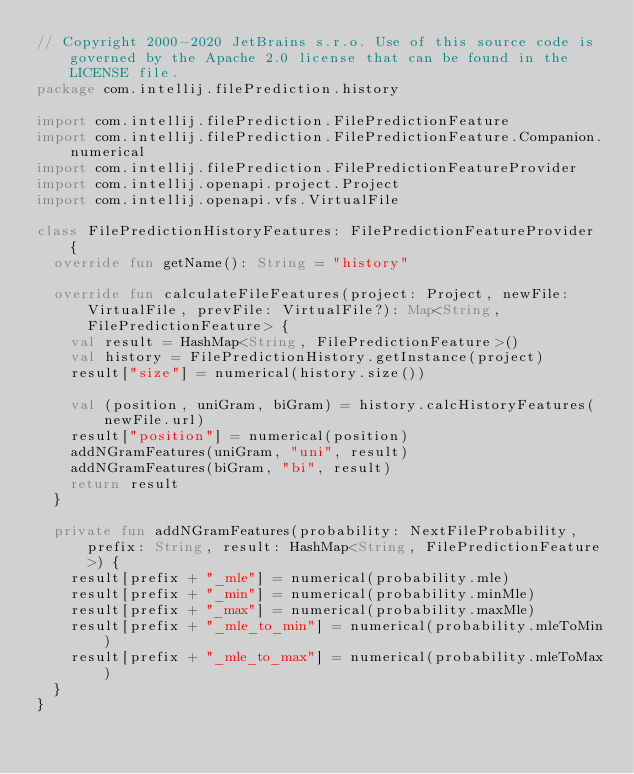<code> <loc_0><loc_0><loc_500><loc_500><_Kotlin_>// Copyright 2000-2020 JetBrains s.r.o. Use of this source code is governed by the Apache 2.0 license that can be found in the LICENSE file.
package com.intellij.filePrediction.history

import com.intellij.filePrediction.FilePredictionFeature
import com.intellij.filePrediction.FilePredictionFeature.Companion.numerical
import com.intellij.filePrediction.FilePredictionFeatureProvider
import com.intellij.openapi.project.Project
import com.intellij.openapi.vfs.VirtualFile

class FilePredictionHistoryFeatures: FilePredictionFeatureProvider {
  override fun getName(): String = "history"

  override fun calculateFileFeatures(project: Project, newFile: VirtualFile, prevFile: VirtualFile?): Map<String, FilePredictionFeature> {
    val result = HashMap<String, FilePredictionFeature>()
    val history = FilePredictionHistory.getInstance(project)
    result["size"] = numerical(history.size())

    val (position, uniGram, biGram) = history.calcHistoryFeatures(newFile.url)
    result["position"] = numerical(position)
    addNGramFeatures(uniGram, "uni", result)
    addNGramFeatures(biGram, "bi", result)
    return result
  }

  private fun addNGramFeatures(probability: NextFileProbability, prefix: String, result: HashMap<String, FilePredictionFeature>) {
    result[prefix + "_mle"] = numerical(probability.mle)
    result[prefix + "_min"] = numerical(probability.minMle)
    result[prefix + "_max"] = numerical(probability.maxMle)
    result[prefix + "_mle_to_min"] = numerical(probability.mleToMin)
    result[prefix + "_mle_to_max"] = numerical(probability.mleToMax)
  }
}
</code> 